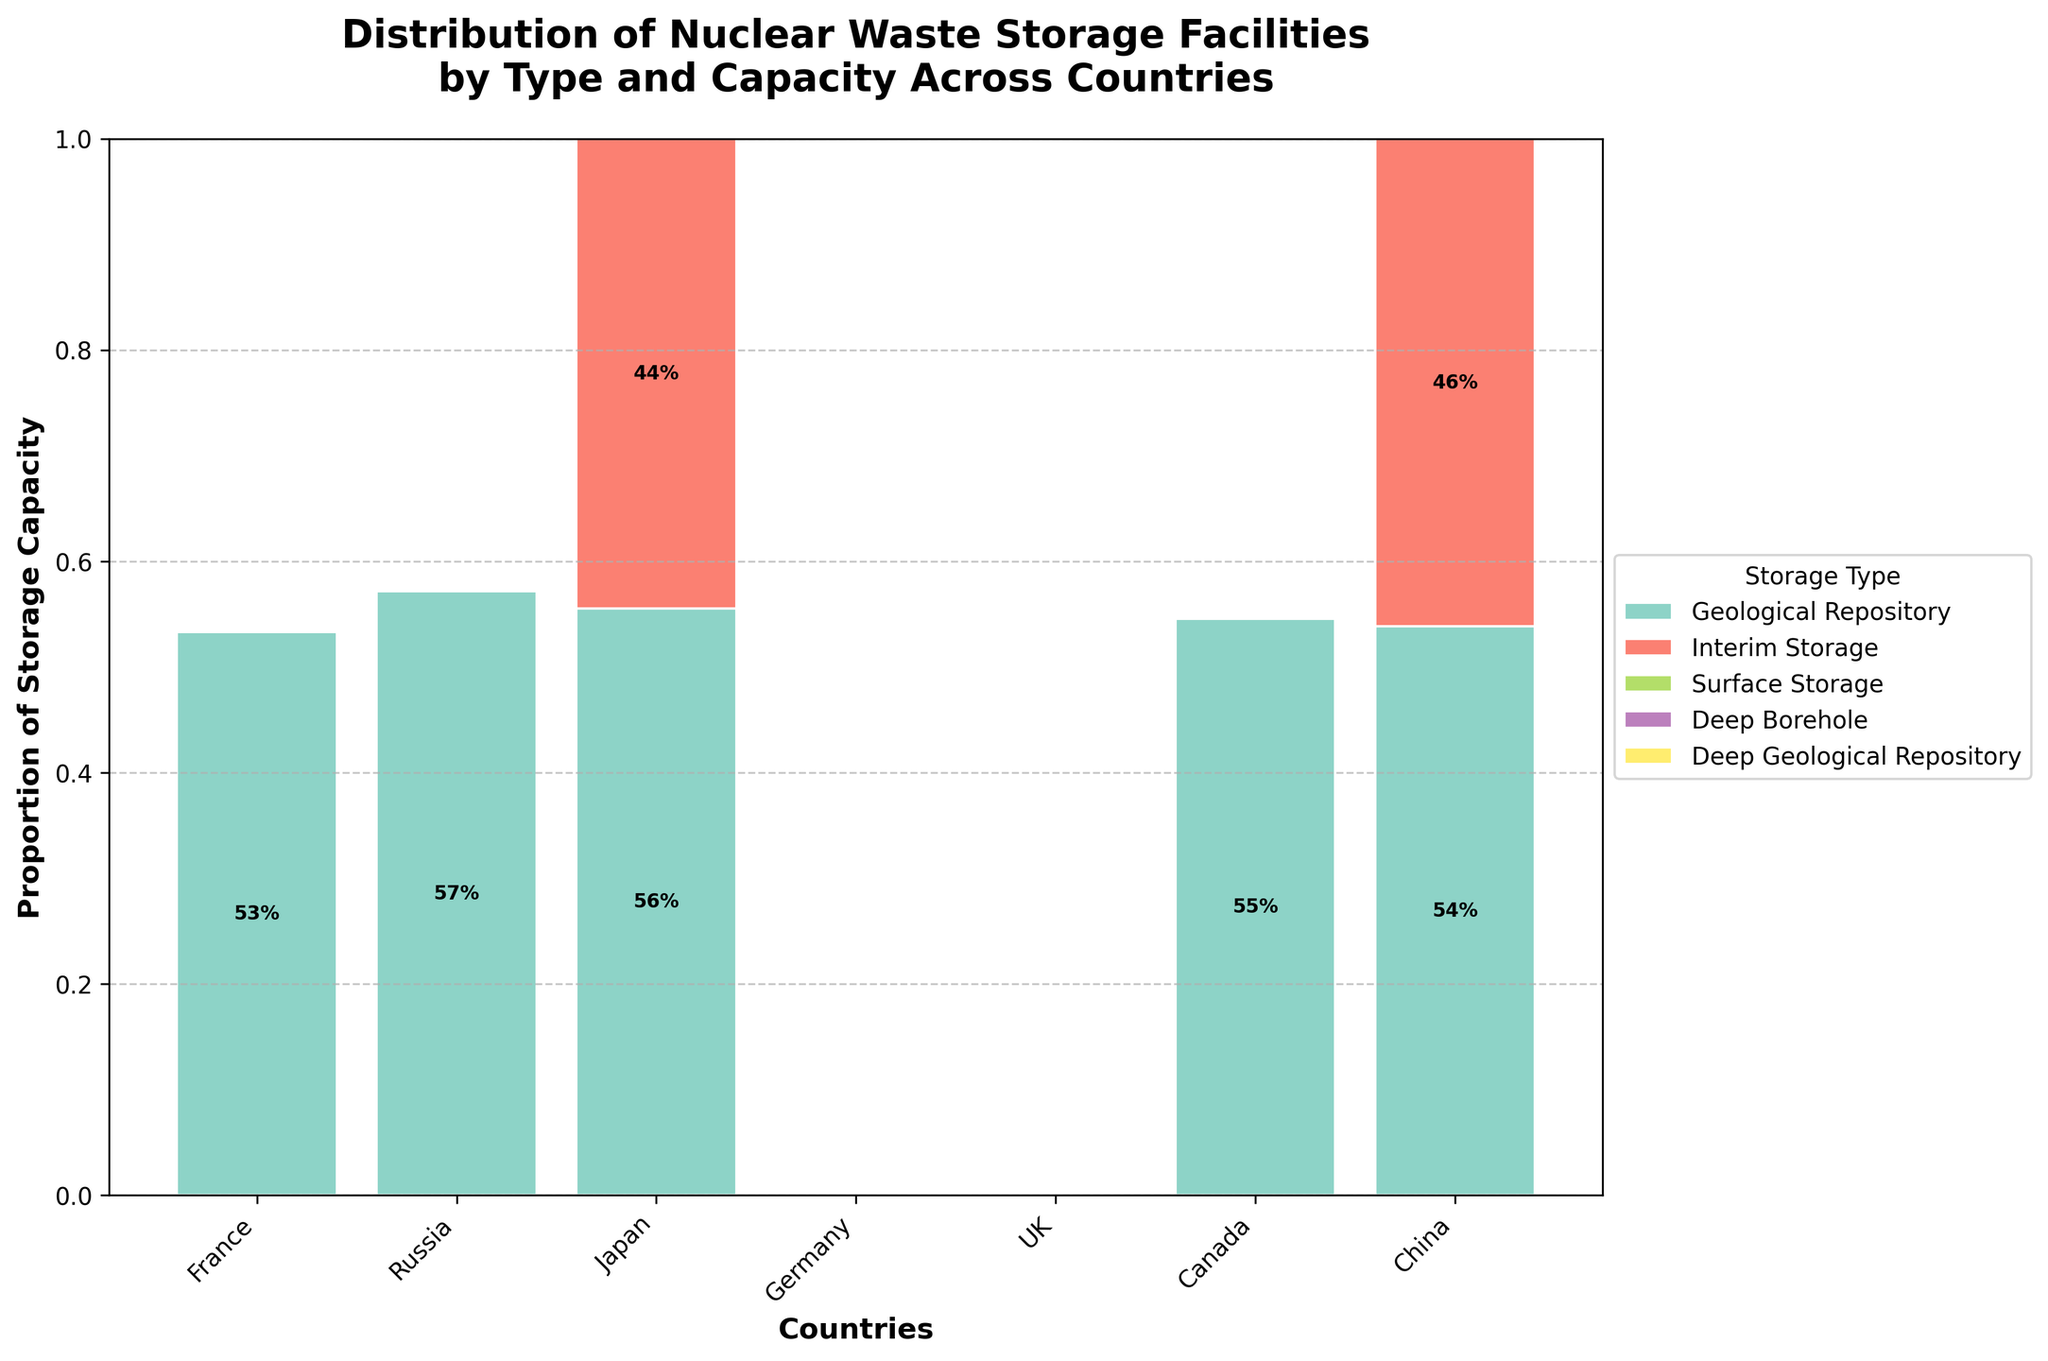What is the title of the plot? The title of the plot is typically found at the top and it summarizes the content of the chart.
Answer: Distribution of Nuclear Waste Storage Facilities by Type and Capacity Across Countries Which country has the largest proportion of Geological Repository storage? Look for the tallest bar segment for Geological Repository storage, which is represented by a specific color.
Answer: USA What is the total number of storage types shown on the plot? Count the distinct segments/colors present in the bars representing different storage types.
Answer: 5 Which country has the most diverse storage types? Identify the country with the highest number of different colored segments in its bar.
Answer: Russia Compare the proportion of Interim Storage between USA and Japan. Which country has a higher proportion? Locate the Interim Storage segments for both countries, then visually compare their heights or proportions.
Answer: USA How does the proportion of Surface Storage in France compare to that in the UK? Look at the Surface Storage segments for France and the UK, then compare their heights.
Answer: France has a higher proportion Which storage type is most common in Canada? Identify the tallest colored segment for Canada, which will denote the most common storage type.
Answer: Interim Storage Describe the visual representation of interim storage across all countries. Locate the consistent color representing Interim Storage in each country's bar, and observe how it varies among the countries.
Answer: Interim Storage is varied, with significant proportions in the USA, Japan, Germany, and Canada What proportion of Russia's storage capacity is in Deep Borehole? Find the segment for Deep Borehole in Russia's bar and note its height/proportion relative to the total bar.
Answer: Approximately 53% Which country has the smallest proportion of Surface Storage and what is it? Identify the shortest or absent Surface Storage segment among all countries with Surface Storage.
Answer: Japan, approximately 20% 